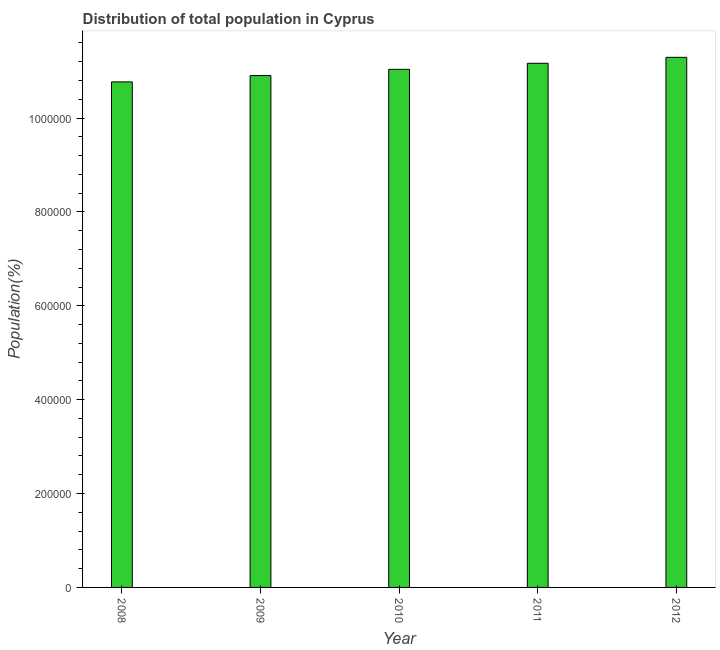What is the title of the graph?
Your response must be concise. Distribution of total population in Cyprus . What is the label or title of the Y-axis?
Provide a short and direct response. Population(%). What is the population in 2012?
Provide a succinct answer. 1.13e+06. Across all years, what is the maximum population?
Provide a succinct answer. 1.13e+06. Across all years, what is the minimum population?
Provide a short and direct response. 1.08e+06. In which year was the population maximum?
Ensure brevity in your answer.  2012. In which year was the population minimum?
Ensure brevity in your answer.  2008. What is the sum of the population?
Your response must be concise. 5.52e+06. What is the difference between the population in 2010 and 2011?
Your response must be concise. -1.30e+04. What is the average population per year?
Provide a short and direct response. 1.10e+06. What is the median population?
Your response must be concise. 1.10e+06. In how many years, is the population greater than 80000 %?
Make the answer very short. 5. What is the ratio of the population in 2008 to that in 2012?
Make the answer very short. 0.95. Is the difference between the population in 2008 and 2009 greater than the difference between any two years?
Make the answer very short. No. What is the difference between the highest and the second highest population?
Offer a terse response. 1.27e+04. Is the sum of the population in 2011 and 2012 greater than the maximum population across all years?
Give a very brief answer. Yes. What is the difference between the highest and the lowest population?
Make the answer very short. 5.23e+04. Are all the bars in the graph horizontal?
Your answer should be compact. No. Are the values on the major ticks of Y-axis written in scientific E-notation?
Provide a short and direct response. No. What is the Population(%) in 2008?
Your response must be concise. 1.08e+06. What is the Population(%) in 2009?
Your answer should be compact. 1.09e+06. What is the Population(%) of 2010?
Your answer should be very brief. 1.10e+06. What is the Population(%) in 2011?
Provide a succinct answer. 1.12e+06. What is the Population(%) of 2012?
Offer a terse response. 1.13e+06. What is the difference between the Population(%) in 2008 and 2009?
Provide a succinct answer. -1.35e+04. What is the difference between the Population(%) in 2008 and 2010?
Your answer should be compact. -2.67e+04. What is the difference between the Population(%) in 2008 and 2011?
Ensure brevity in your answer.  -3.96e+04. What is the difference between the Population(%) in 2008 and 2012?
Your answer should be compact. -5.23e+04. What is the difference between the Population(%) in 2009 and 2010?
Keep it short and to the point. -1.32e+04. What is the difference between the Population(%) in 2009 and 2011?
Offer a terse response. -2.62e+04. What is the difference between the Population(%) in 2009 and 2012?
Provide a short and direct response. -3.88e+04. What is the difference between the Population(%) in 2010 and 2011?
Make the answer very short. -1.30e+04. What is the difference between the Population(%) in 2010 and 2012?
Your response must be concise. -2.56e+04. What is the difference between the Population(%) in 2011 and 2012?
Your answer should be very brief. -1.27e+04. What is the ratio of the Population(%) in 2008 to that in 2010?
Your response must be concise. 0.98. What is the ratio of the Population(%) in 2008 to that in 2011?
Keep it short and to the point. 0.96. What is the ratio of the Population(%) in 2008 to that in 2012?
Ensure brevity in your answer.  0.95. What is the ratio of the Population(%) in 2009 to that in 2010?
Your answer should be very brief. 0.99. What is the ratio of the Population(%) in 2009 to that in 2011?
Make the answer very short. 0.98. What is the ratio of the Population(%) in 2009 to that in 2012?
Provide a short and direct response. 0.97. 